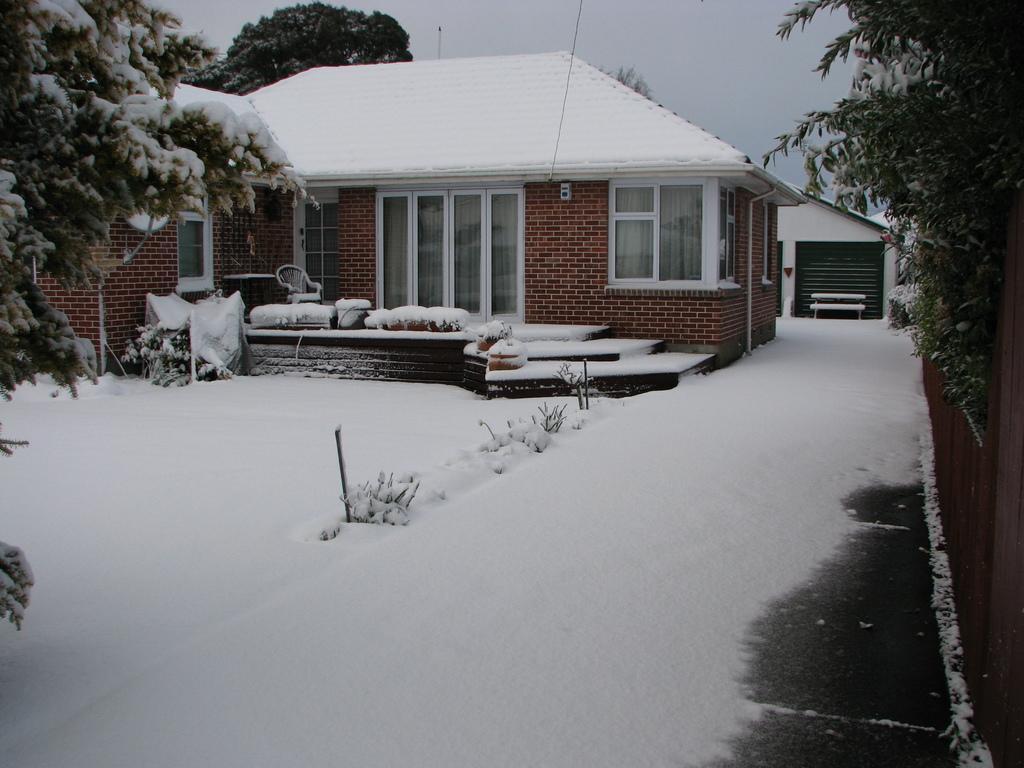Describe this image in one or two sentences. In this picture we can observe a house. There is some snow on the house and on the ground. We can observe some trees. In the background there is a sky. 